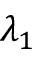<formula> <loc_0><loc_0><loc_500><loc_500>\lambda _ { 1 }</formula> 